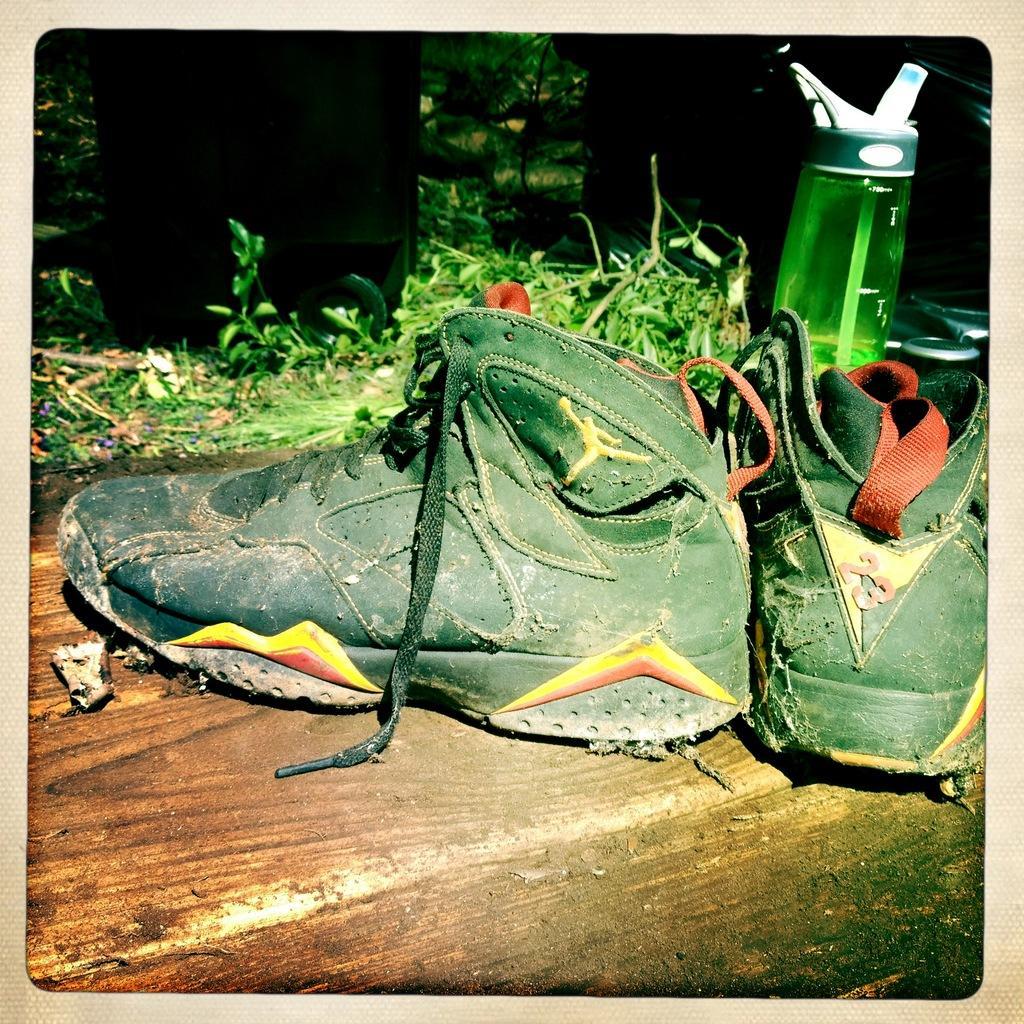Please provide a concise description of this image. In this image, there are some shoe which are in green color, there is a bottle which is in green color, in the background there are some green color plants. 